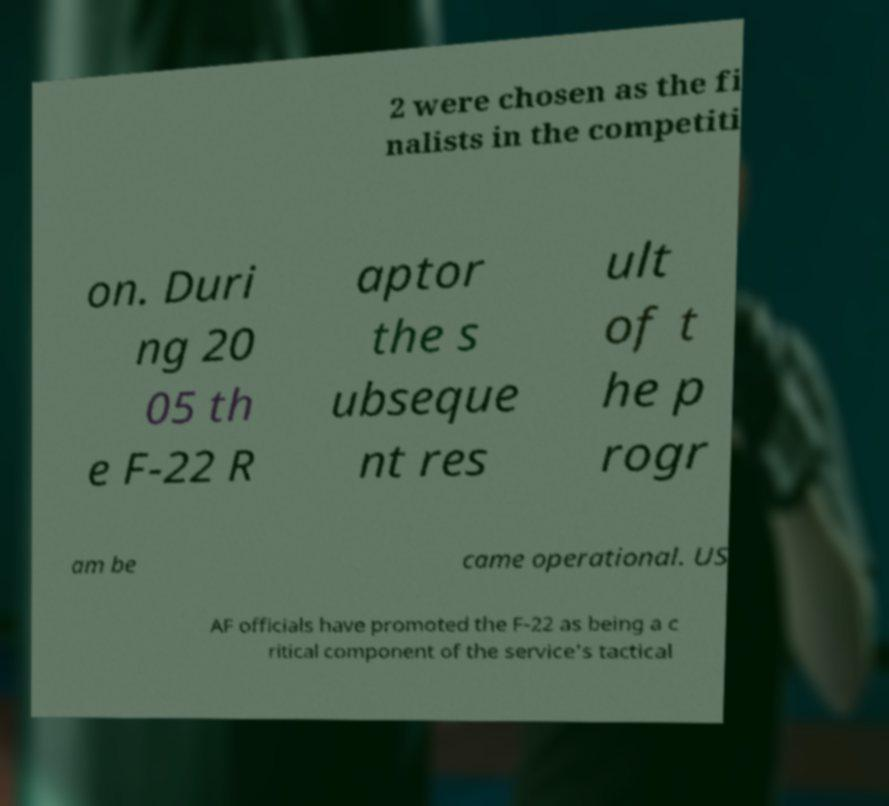Please read and relay the text visible in this image. What does it say? 2 were chosen as the fi nalists in the competiti on. Duri ng 20 05 th e F-22 R aptor the s ubseque nt res ult of t he p rogr am be came operational. US AF officials have promoted the F-22 as being a c ritical component of the service's tactical 